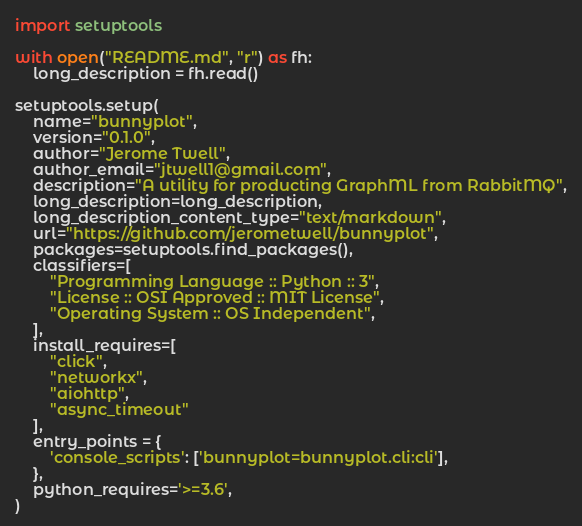Convert code to text. <code><loc_0><loc_0><loc_500><loc_500><_Python_>import setuptools

with open("README.md", "r") as fh:
    long_description = fh.read()

setuptools.setup(
    name="bunnyplot",
    version="0.1.0",
    author="Jerome Twell",
    author_email="jtwell1@gmail.com",
    description="A utility for producting GraphML from RabbitMQ",
    long_description=long_description,
    long_description_content_type="text/markdown",
    url="https://github.com/jerometwell/bunnyplot",
    packages=setuptools.find_packages(),
    classifiers=[
        "Programming Language :: Python :: 3",
        "License :: OSI Approved :: MIT License",
        "Operating System :: OS Independent",
    ],
    install_requires=[
        "click",
        "networkx",
        "aiohttp",
        "async_timeout"
    ],
    entry_points = {
        'console_scripts': ['bunnyplot=bunnyplot.cli:cli'],
    },
    python_requires='>=3.6',
)</code> 